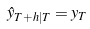<formula> <loc_0><loc_0><loc_500><loc_500>\hat { y } _ { T + h | T } = y _ { T }</formula> 